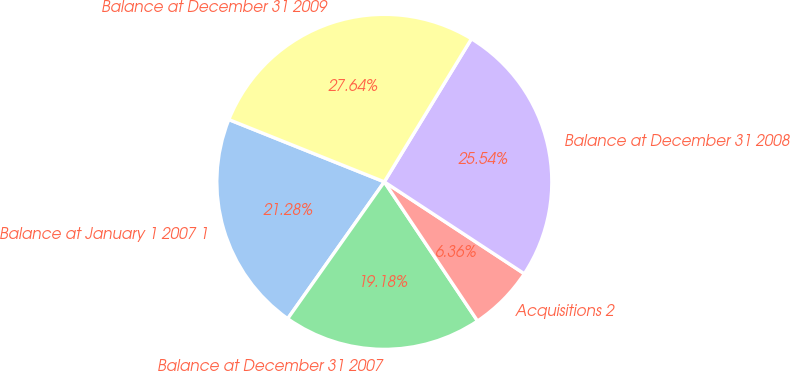<chart> <loc_0><loc_0><loc_500><loc_500><pie_chart><fcel>Balance at January 1 2007 1<fcel>Balance at December 31 2007<fcel>Acquisitions 2<fcel>Balance at December 31 2008<fcel>Balance at December 31 2009<nl><fcel>21.28%<fcel>19.18%<fcel>6.36%<fcel>25.54%<fcel>27.64%<nl></chart> 